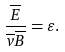<formula> <loc_0><loc_0><loc_500><loc_500>\frac { \overline { E } } { \overline { v } \overline { B } } = \varepsilon .</formula> 